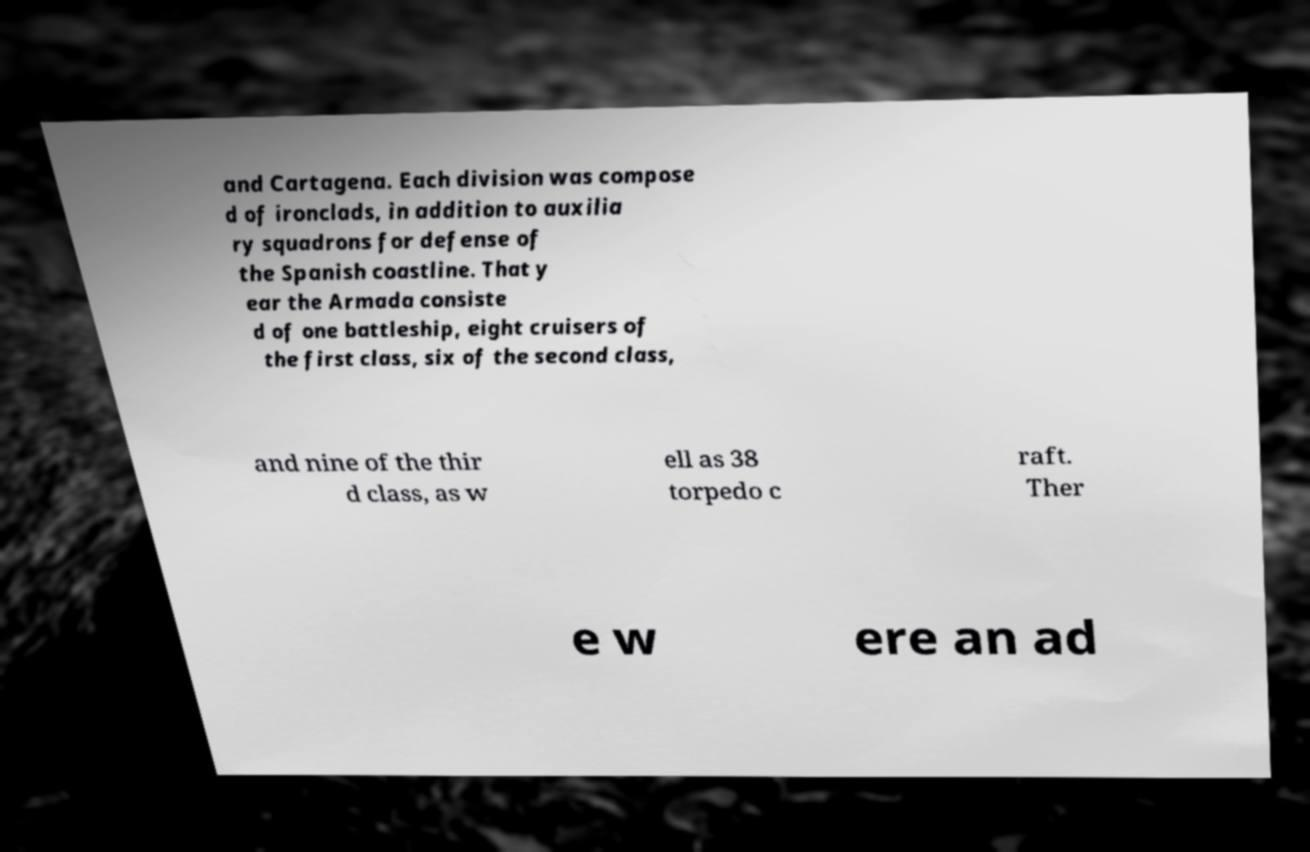Can you read and provide the text displayed in the image?This photo seems to have some interesting text. Can you extract and type it out for me? and Cartagena. Each division was compose d of ironclads, in addition to auxilia ry squadrons for defense of the Spanish coastline. That y ear the Armada consiste d of one battleship, eight cruisers of the first class, six of the second class, and nine of the thir d class, as w ell as 38 torpedo c raft. Ther e w ere an ad 